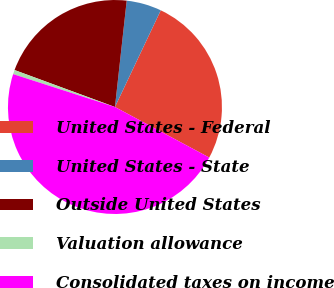Convert chart. <chart><loc_0><loc_0><loc_500><loc_500><pie_chart><fcel>United States - Federal<fcel>United States - State<fcel>Outside United States<fcel>Valuation allowance<fcel>Consolidated taxes on income<nl><fcel>25.79%<fcel>5.29%<fcel>21.14%<fcel>0.64%<fcel>47.14%<nl></chart> 